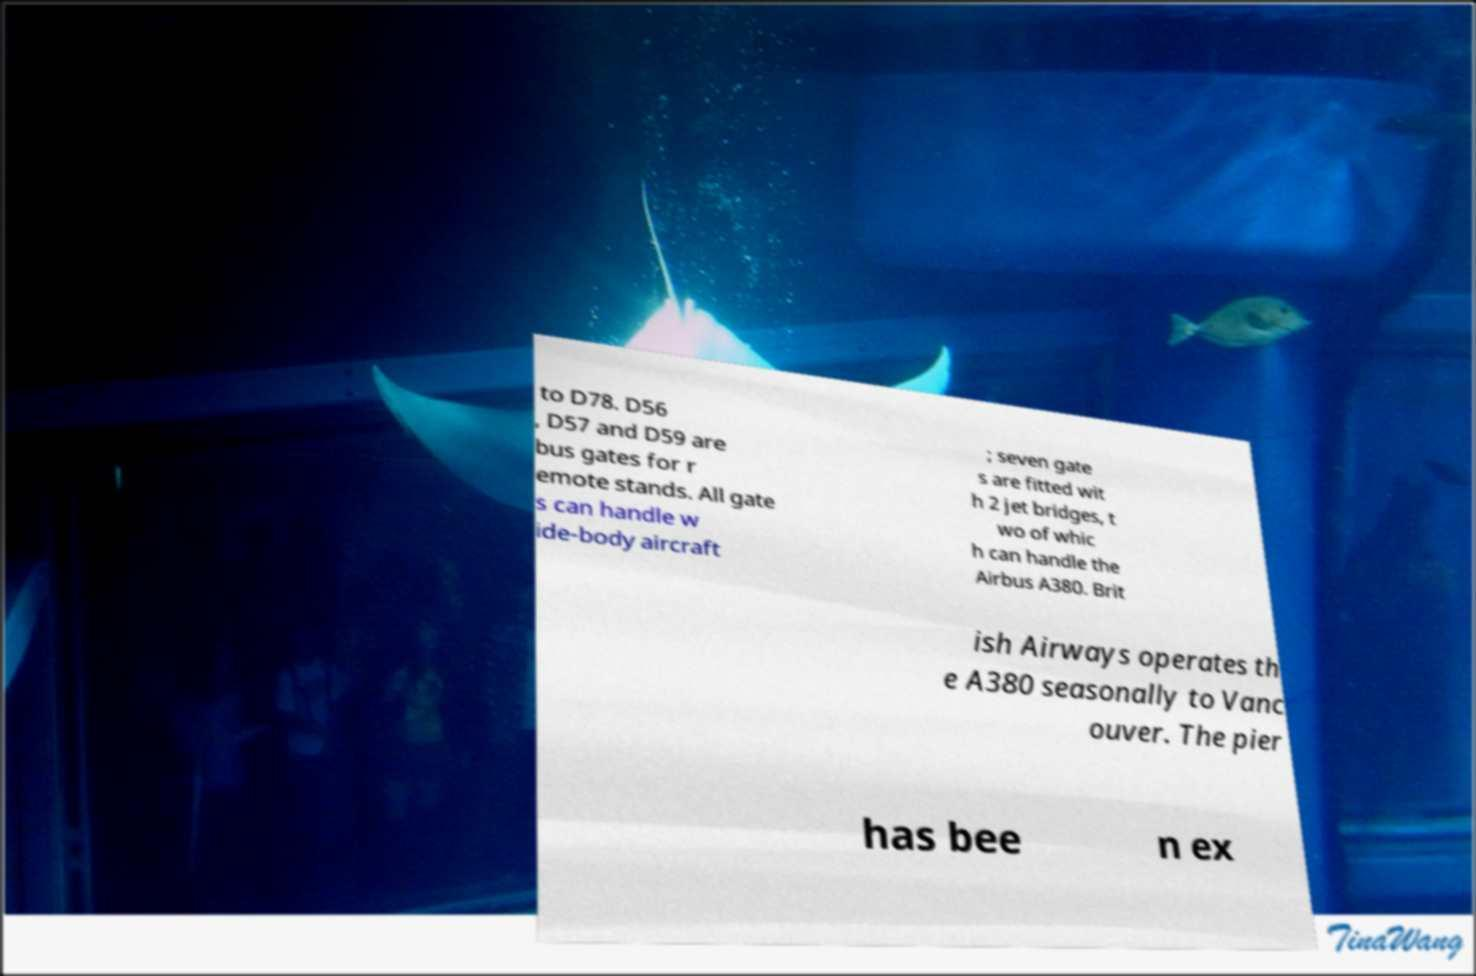There's text embedded in this image that I need extracted. Can you transcribe it verbatim? to D78. D56 , D57 and D59 are bus gates for r emote stands. All gate s can handle w ide-body aircraft ; seven gate s are fitted wit h 2 jet bridges, t wo of whic h can handle the Airbus A380. Brit ish Airways operates th e A380 seasonally to Vanc ouver. The pier has bee n ex 